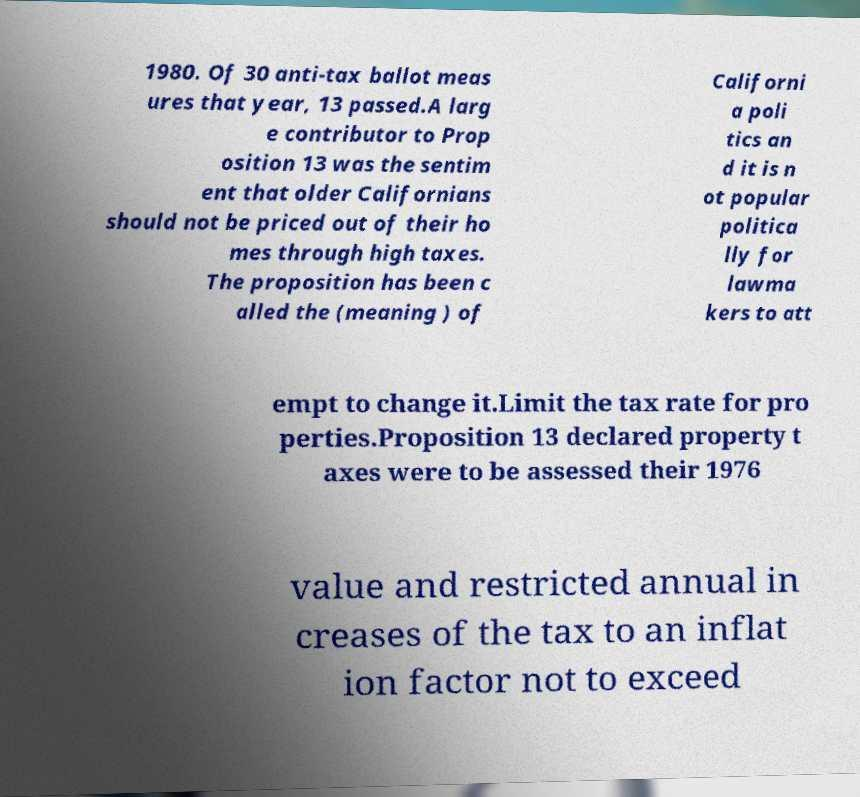There's text embedded in this image that I need extracted. Can you transcribe it verbatim? 1980. Of 30 anti-tax ballot meas ures that year, 13 passed.A larg e contributor to Prop osition 13 was the sentim ent that older Californians should not be priced out of their ho mes through high taxes. The proposition has been c alled the (meaning ) of Californi a poli tics an d it is n ot popular politica lly for lawma kers to att empt to change it.Limit the tax rate for pro perties.Proposition 13 declared property t axes were to be assessed their 1976 value and restricted annual in creases of the tax to an inflat ion factor not to exceed 